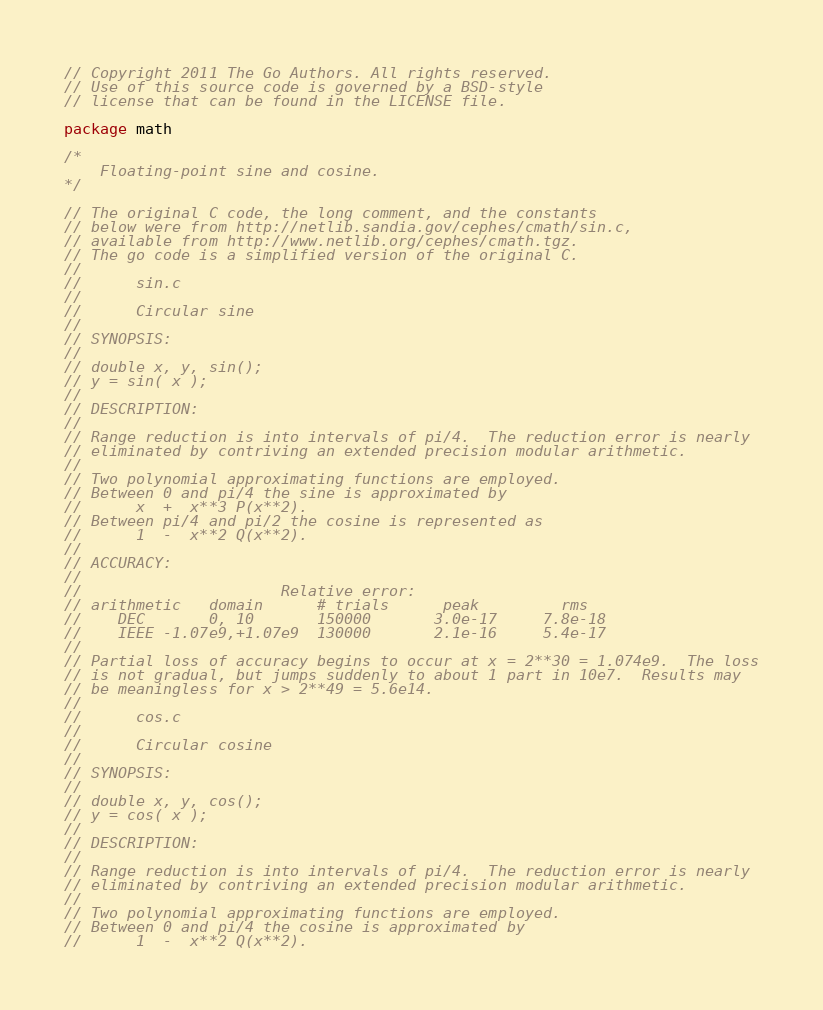<code> <loc_0><loc_0><loc_500><loc_500><_Go_>// Copyright 2011 The Go Authors. All rights reserved.
// Use of this source code is governed by a BSD-style
// license that can be found in the LICENSE file.

package math

/*
	Floating-point sine and cosine.
*/

// The original C code, the long comment, and the constants
// below were from http://netlib.sandia.gov/cephes/cmath/sin.c,
// available from http://www.netlib.org/cephes/cmath.tgz.
// The go code is a simplified version of the original C.
//
//      sin.c
//
//      Circular sine
//
// SYNOPSIS:
//
// double x, y, sin();
// y = sin( x );
//
// DESCRIPTION:
//
// Range reduction is into intervals of pi/4.  The reduction error is nearly
// eliminated by contriving an extended precision modular arithmetic.
//
// Two polynomial approximating functions are employed.
// Between 0 and pi/4 the sine is approximated by
//      x  +  x**3 P(x**2).
// Between pi/4 and pi/2 the cosine is represented as
//      1  -  x**2 Q(x**2).
//
// ACCURACY:
//
//                      Relative error:
// arithmetic   domain      # trials      peak         rms
//    DEC       0, 10       150000       3.0e-17     7.8e-18
//    IEEE -1.07e9,+1.07e9  130000       2.1e-16     5.4e-17
//
// Partial loss of accuracy begins to occur at x = 2**30 = 1.074e9.  The loss
// is not gradual, but jumps suddenly to about 1 part in 10e7.  Results may
// be meaningless for x > 2**49 = 5.6e14.
//
//      cos.c
//
//      Circular cosine
//
// SYNOPSIS:
//
// double x, y, cos();
// y = cos( x );
//
// DESCRIPTION:
//
// Range reduction is into intervals of pi/4.  The reduction error is nearly
// eliminated by contriving an extended precision modular arithmetic.
//
// Two polynomial approximating functions are employed.
// Between 0 and pi/4 the cosine is approximated by
//      1  -  x**2 Q(x**2).</code> 